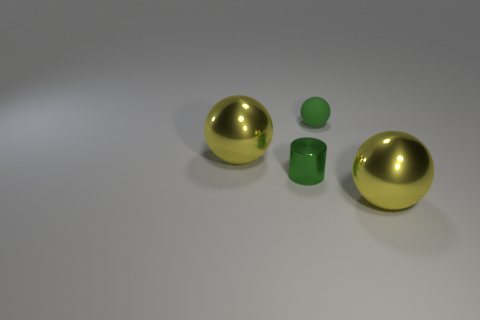What is the material of the small object that is the same color as the rubber ball?
Keep it short and to the point. Metal. There is a large shiny object that is behind the green shiny object; is it the same color as the metal ball that is to the right of the small green rubber sphere?
Your answer should be compact. Yes. There is a small object behind the small green metal object; does it have the same color as the tiny shiny thing?
Your answer should be compact. Yes. What is the material of the thing that is both left of the green rubber sphere and behind the cylinder?
Make the answer very short. Metal. Is there a matte object that has the same size as the green metal cylinder?
Keep it short and to the point. Yes. What number of big gray matte balls are there?
Ensure brevity in your answer.  0. There is a green matte ball; how many big yellow metal spheres are to the right of it?
Offer a very short reply. 1. How many green things are both behind the small green cylinder and in front of the small green sphere?
Keep it short and to the point. 0. How many other objects are there of the same color as the tiny matte thing?
Provide a succinct answer. 1. How many brown objects are either matte spheres or large metallic blocks?
Provide a short and direct response. 0. 